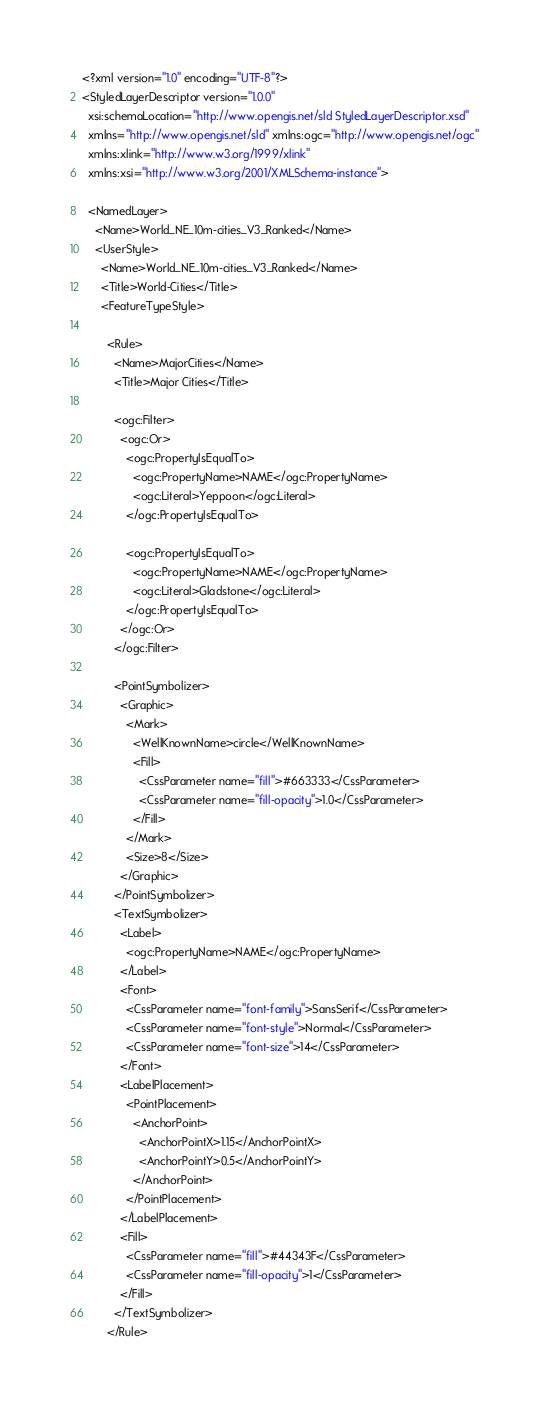<code> <loc_0><loc_0><loc_500><loc_500><_Scheme_><?xml version="1.0" encoding="UTF-8"?>
<StyledLayerDescriptor version="1.0.0"
  xsi:schemaLocation="http://www.opengis.net/sld StyledLayerDescriptor.xsd"
  xmlns="http://www.opengis.net/sld" xmlns:ogc="http://www.opengis.net/ogc"
  xmlns:xlink="http://www.w3.org/1999/xlink"
  xmlns:xsi="http://www.w3.org/2001/XMLSchema-instance">

  <NamedLayer>
    <Name>World_NE_10m-cities_V3_Ranked</Name>
    <UserStyle>
      <Name>World_NE_10m-cities_V3_Ranked</Name>
      <Title>World-Cities</Title>
      <FeatureTypeStyle>

        <Rule>
          <Name>MajorCities</Name>
          <Title>Major Cities</Title>

          <ogc:Filter>
            <ogc:Or>
              <ogc:PropertyIsEqualTo>
                <ogc:PropertyName>NAME</ogc:PropertyName>
                <ogc:Literal>Yeppoon</ogc:Literal>
              </ogc:PropertyIsEqualTo>

              <ogc:PropertyIsEqualTo>
                <ogc:PropertyName>NAME</ogc:PropertyName>
                <ogc:Literal>Gladstone</ogc:Literal>
              </ogc:PropertyIsEqualTo>
            </ogc:Or>
          </ogc:Filter>

          <PointSymbolizer>
            <Graphic>
              <Mark>
                <WellKnownName>circle</WellKnownName>
                <Fill>
                  <CssParameter name="fill">#663333</CssParameter>
                  <CssParameter name="fill-opacity">1.0</CssParameter>
                </Fill>
              </Mark>
              <Size>8</Size>
            </Graphic>
          </PointSymbolizer>
          <TextSymbolizer>
            <Label>
              <ogc:PropertyName>NAME</ogc:PropertyName>
            </Label>
            <Font>
              <CssParameter name="font-family">SansSerif</CssParameter>
              <CssParameter name="font-style">Normal</CssParameter>
              <CssParameter name="font-size">14</CssParameter>
            </Font>
            <LabelPlacement>
              <PointPlacement>
                <AnchorPoint>
                  <AnchorPointX>1.15</AnchorPointX>
                  <AnchorPointY>0.5</AnchorPointY>
                </AnchorPoint>
              </PointPlacement>
            </LabelPlacement>
            <Fill>
              <CssParameter name="fill">#44343F</CssParameter>
              <CssParameter name="fill-opacity">1</CssParameter>
            </Fill>
          </TextSymbolizer>
        </Rule>
</code> 